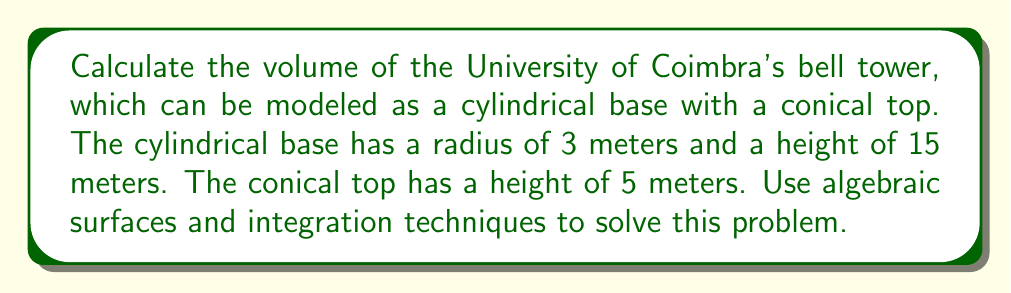Could you help me with this problem? Let's approach this problem step-by-step using algebraic surfaces and integration techniques:

1) First, we need to set up our coordinate system. Let's place the origin at the center of the base of the cylinder, with the z-axis pointing upwards.

2) The cylinder can be described by the equation:
   $$x^2 + y^2 = 9, 0 \leq z \leq 15$$

3) The cone can be described by the equation:
   $$\frac{x^2 + y^2}{9} = \frac{(20-z)^2}{25}, 15 \leq z \leq 20$$

4) To calculate the volume, we'll use cylindrical coordinates $(r, \theta, z)$ and the triple integral:
   $$V = \int_0^{2\pi} \int_0^R \int_0^H r \, dz \, dr \, d\theta$$

5) For the cylinder:
   $$V_c = \int_0^{2\pi} \int_0^3 \int_0^{15} r \, dz \, dr \, d\theta$$
   $$= 2\pi \int_0^3 \int_0^{15} r \, dz \, dr$$
   $$= 2\pi \int_0^3 15r \, dr$$
   $$= 2\pi \cdot \frac{15r^2}{2}\Big|_0^3$$
   $$= 45\pi \cdot 3$$
   $$= 135\pi$$

6) For the cone:
   $$V_n = \int_0^{2\pi} \int_0^3 \int_{15}^{20-\frac{5r}{3}} r \, dz \, dr \, d\theta$$
   $$= 2\pi \int_0^3 \int_{15}^{20-\frac{5r}{3}} r \, dz \, dr$$
   $$= 2\pi \int_0^3 r(5-\frac{5r}{3}) \, dr$$
   $$= 2\pi \int_0^3 (5r-\frac{5r^2}{3}) \, dr$$
   $$= 2\pi \left[\frac{5r^2}{2}-\frac{5r^3}{9}\right]_0^3$$
   $$= 2\pi \left(\frac{45}{2}-\frac{45}{3}\right)$$
   $$= 2\pi \cdot \frac{15}{2}$$
   $$= 15\pi$$

7) The total volume is the sum of the cylinder and cone volumes:
   $$V_{total} = V_c + V_n = 135\pi + 15\pi = 150\pi$$

Therefore, the volume of the bell tower is $150\pi$ cubic meters.
Answer: $150\pi$ cubic meters 